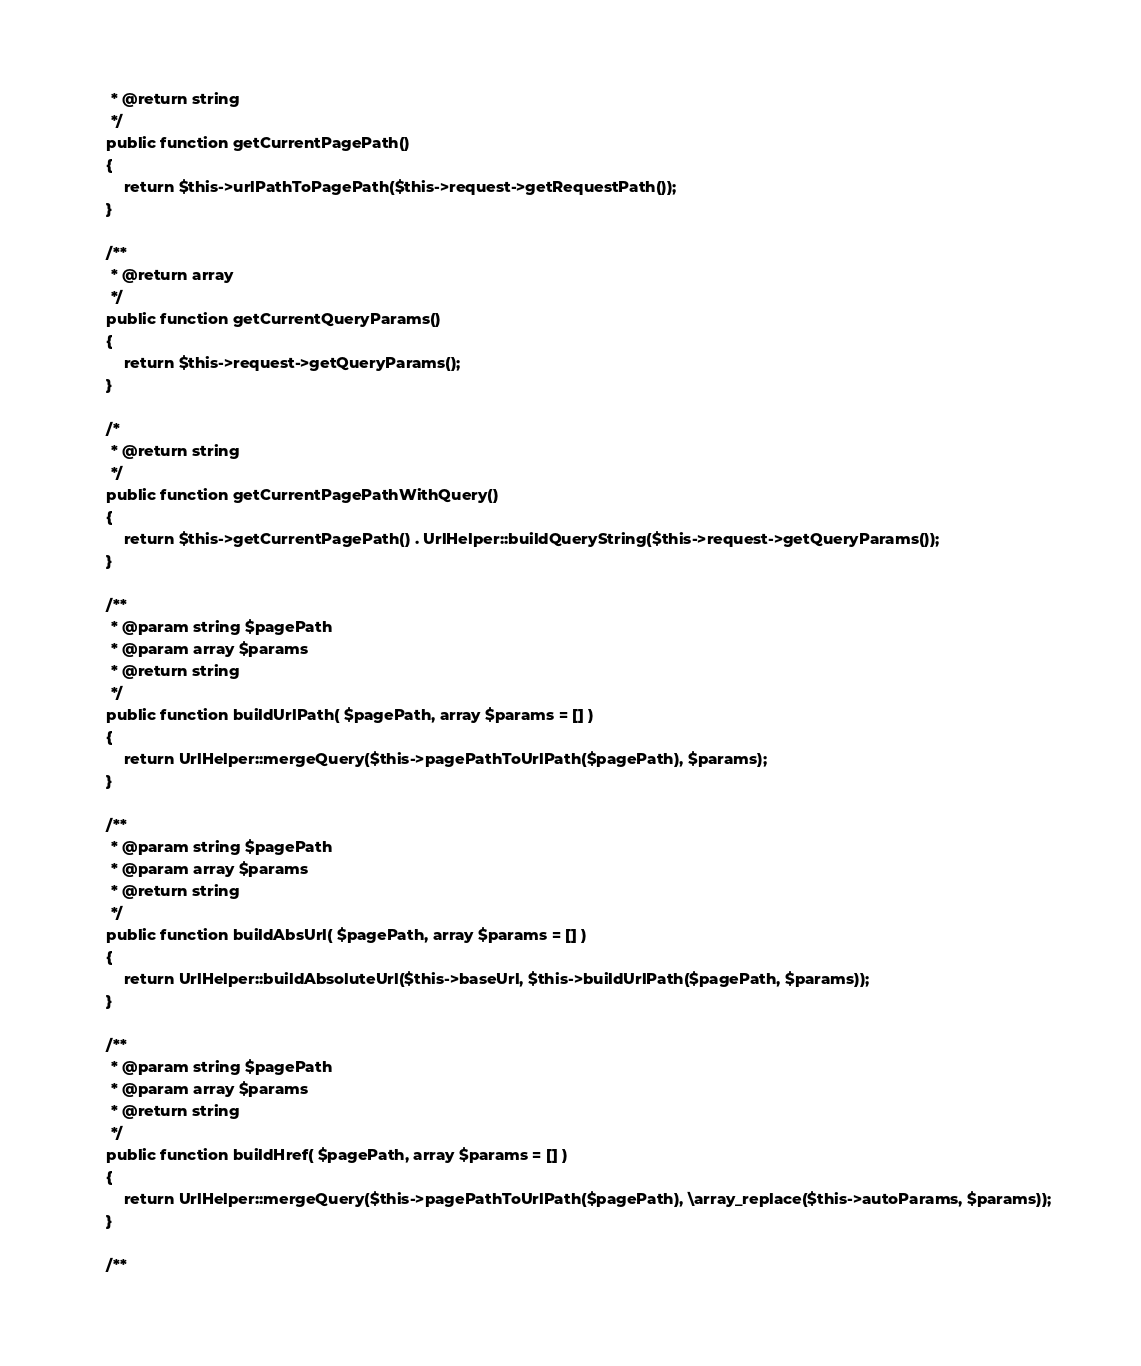<code> <loc_0><loc_0><loc_500><loc_500><_PHP_>	 * @return string
	 */
	public function getCurrentPagePath()
	{
		return $this->urlPathToPagePath($this->request->getRequestPath());
	}

	/**
	 * @return array
	 */
	public function getCurrentQueryParams()
	{
		return $this->request->getQueryParams();
	}

	/*
	 * @return string
	 */
	public function getCurrentPagePathWithQuery()
	{
		return $this->getCurrentPagePath() . UrlHelper::buildQueryString($this->request->getQueryParams());
	}

	/**
	 * @param string $pagePath
	 * @param array $params
	 * @return string
	 */
	public function buildUrlPath( $pagePath, array $params = [] )
	{
		return UrlHelper::mergeQuery($this->pagePathToUrlPath($pagePath), $params);
	}

	/**
	 * @param string $pagePath
	 * @param array $params
	 * @return string
	 */
	public function buildAbsUrl( $pagePath, array $params = [] )
	{
		return UrlHelper::buildAbsoluteUrl($this->baseUrl, $this->buildUrlPath($pagePath, $params));
	}

	/**
	 * @param string $pagePath
	 * @param array $params
	 * @return string
	 */
	public function buildHref( $pagePath, array $params = [] )
	{
		return UrlHelper::mergeQuery($this->pagePathToUrlPath($pagePath), \array_replace($this->autoParams, $params));
	}

	/**</code> 